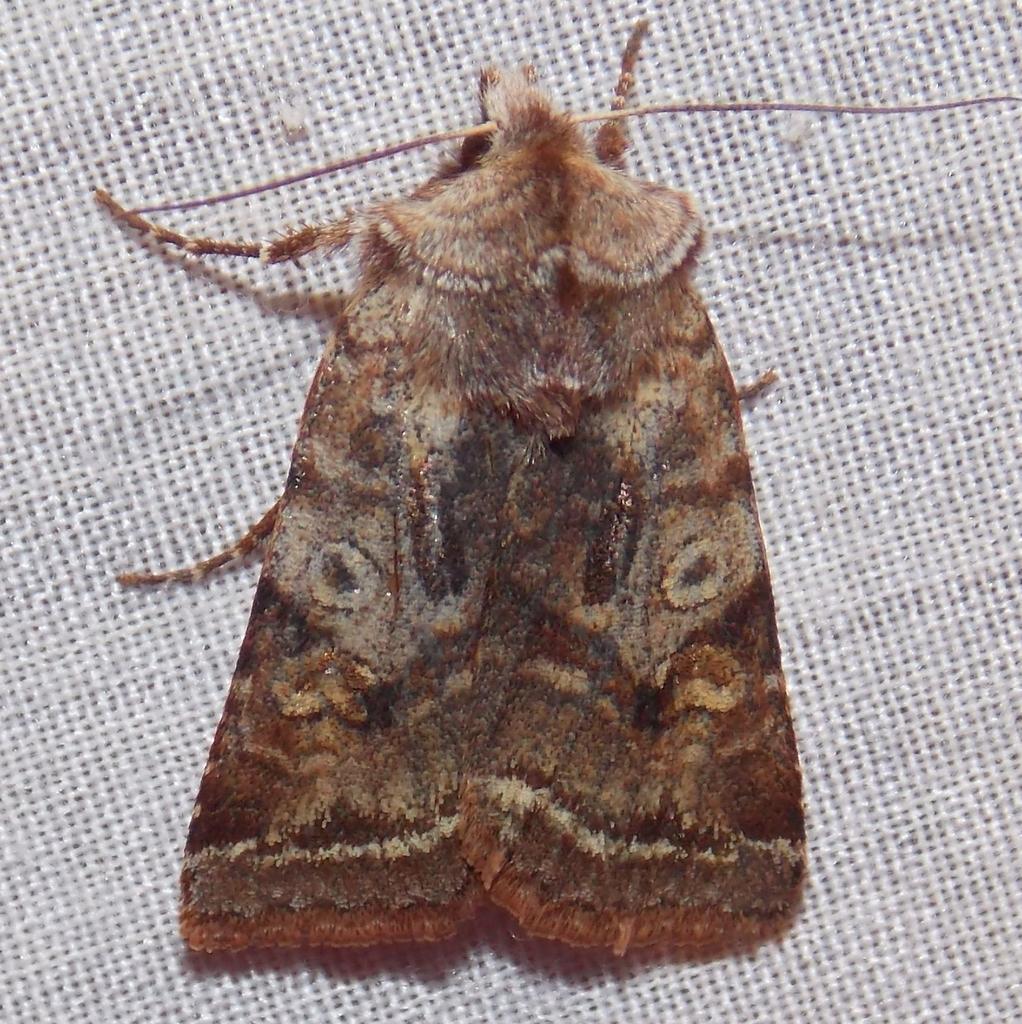Could you give a brief overview of what you see in this image? In this image there is an insect on the surface. 